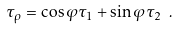Convert formula to latex. <formula><loc_0><loc_0><loc_500><loc_500>\tau _ { \rho } = \cos \varphi \tau _ { 1 } + \sin \varphi \tau _ { 2 } \ .</formula> 